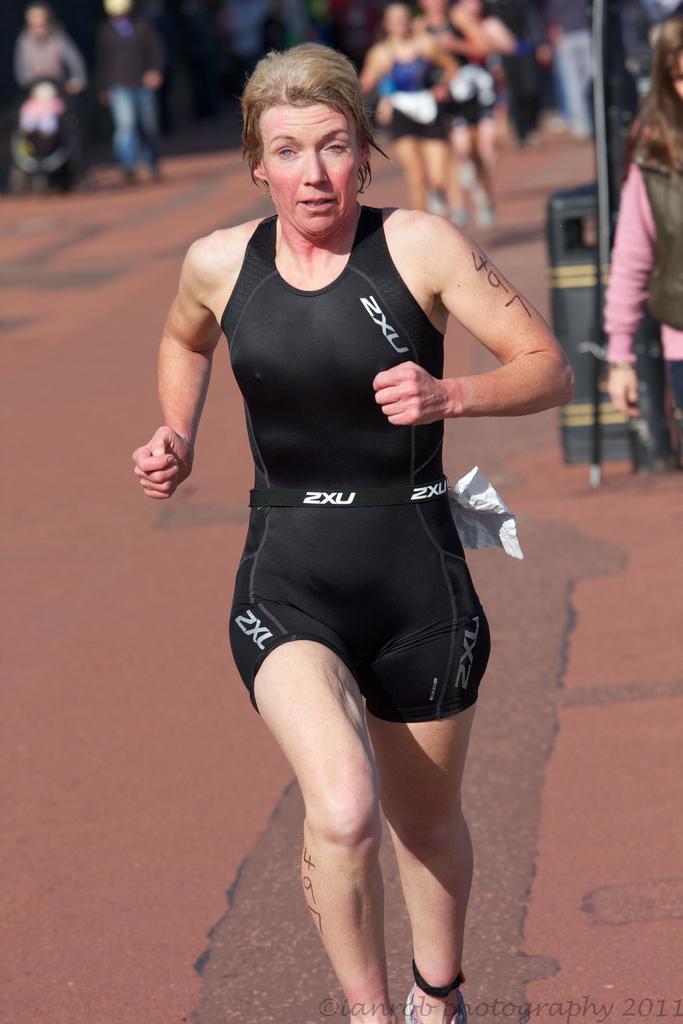What is the main subject of the image? The main subject of the image is a lady running in the center of the image. What is the lady wearing? The lady is wearing a black dress. What can be seen in the background of the image? There are people in the background of the image. What is at the bottom of the image? There is a road at the bottom of the image. What type of government is depicted in the image? There is no depiction of a government in the image; it features a lady running in a black dress. Can you tell me how many frogs are present in the image? There are no frogs present in the image. 